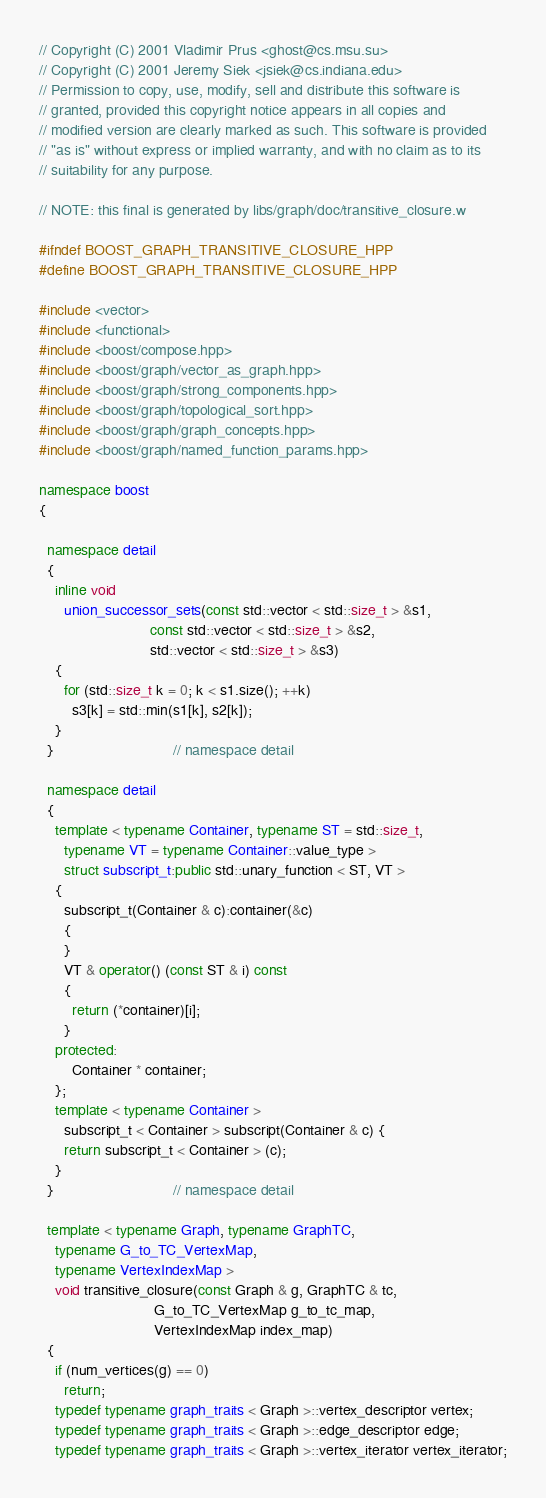<code> <loc_0><loc_0><loc_500><loc_500><_C++_>// Copyright (C) 2001 Vladimir Prus <ghost@cs.msu.su>
// Copyright (C) 2001 Jeremy Siek <jsiek@cs.indiana.edu>
// Permission to copy, use, modify, sell and distribute this software is
// granted, provided this copyright notice appears in all copies and 
// modified version are clearly marked as such. This software is provided
// "as is" without express or implied warranty, and with no claim as to its
// suitability for any purpose.

// NOTE: this final is generated by libs/graph/doc/transitive_closure.w

#ifndef BOOST_GRAPH_TRANSITIVE_CLOSURE_HPP
#define BOOST_GRAPH_TRANSITIVE_CLOSURE_HPP

#include <vector>
#include <functional>
#include <boost/compose.hpp>
#include <boost/graph/vector_as_graph.hpp>
#include <boost/graph/strong_components.hpp>
#include <boost/graph/topological_sort.hpp>
#include <boost/graph/graph_concepts.hpp>
#include <boost/graph/named_function_params.hpp>

namespace boost
{

  namespace detail
  {
    inline void
      union_successor_sets(const std::vector < std::size_t > &s1,
                           const std::vector < std::size_t > &s2,
                           std::vector < std::size_t > &s3)
    {
      for (std::size_t k = 0; k < s1.size(); ++k)
        s3[k] = std::min(s1[k], s2[k]);
    }
  }                             // namespace detail

  namespace detail
  {
    template < typename Container, typename ST = std::size_t,
      typename VT = typename Container::value_type >
      struct subscript_t:public std::unary_function < ST, VT >
    {
      subscript_t(Container & c):container(&c)
      {
      }
      VT & operator() (const ST & i) const
      {
        return (*container)[i];
      }
    protected:
        Container * container;
    };
    template < typename Container >
      subscript_t < Container > subscript(Container & c) {
      return subscript_t < Container > (c);
    }
  }                             // namespace detail

  template < typename Graph, typename GraphTC,
    typename G_to_TC_VertexMap,
    typename VertexIndexMap >
    void transitive_closure(const Graph & g, GraphTC & tc,
                            G_to_TC_VertexMap g_to_tc_map,
                            VertexIndexMap index_map)
  {
    if (num_vertices(g) == 0)
      return;
    typedef typename graph_traits < Graph >::vertex_descriptor vertex;
    typedef typename graph_traits < Graph >::edge_descriptor edge;
    typedef typename graph_traits < Graph >::vertex_iterator vertex_iterator;</code> 